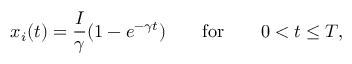Convert formula to latex. <formula><loc_0><loc_0><loc_500><loc_500>x _ { i } ( t ) = \frac { I } { \gamma } ( 1 - e ^ { - \gamma t } ) \quad f o r \quad 0 < t \leq T ,</formula> 